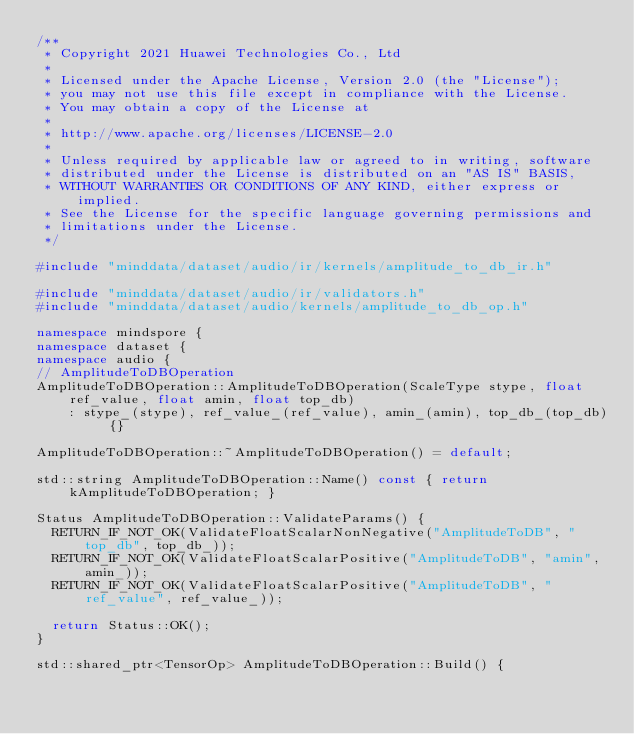Convert code to text. <code><loc_0><loc_0><loc_500><loc_500><_C++_>/**
 * Copyright 2021 Huawei Technologies Co., Ltd
 *
 * Licensed under the Apache License, Version 2.0 (the "License");
 * you may not use this file except in compliance with the License.
 * You may obtain a copy of the License at
 *
 * http://www.apache.org/licenses/LICENSE-2.0
 *
 * Unless required by applicable law or agreed to in writing, software
 * distributed under the License is distributed on an "AS IS" BASIS,
 * WITHOUT WARRANTIES OR CONDITIONS OF ANY KIND, either express or implied.
 * See the License for the specific language governing permissions and
 * limitations under the License.
 */

#include "minddata/dataset/audio/ir/kernels/amplitude_to_db_ir.h"

#include "minddata/dataset/audio/ir/validators.h"
#include "minddata/dataset/audio/kernels/amplitude_to_db_op.h"

namespace mindspore {
namespace dataset {
namespace audio {
// AmplitudeToDBOperation
AmplitudeToDBOperation::AmplitudeToDBOperation(ScaleType stype, float ref_value, float amin, float top_db)
    : stype_(stype), ref_value_(ref_value), amin_(amin), top_db_(top_db) {}

AmplitudeToDBOperation::~AmplitudeToDBOperation() = default;

std::string AmplitudeToDBOperation::Name() const { return kAmplitudeToDBOperation; }

Status AmplitudeToDBOperation::ValidateParams() {
  RETURN_IF_NOT_OK(ValidateFloatScalarNonNegative("AmplitudeToDB", "top_db", top_db_));
  RETURN_IF_NOT_OK(ValidateFloatScalarPositive("AmplitudeToDB", "amin", amin_));
  RETURN_IF_NOT_OK(ValidateFloatScalarPositive("AmplitudeToDB", "ref_value", ref_value_));

  return Status::OK();
}

std::shared_ptr<TensorOp> AmplitudeToDBOperation::Build() {</code> 